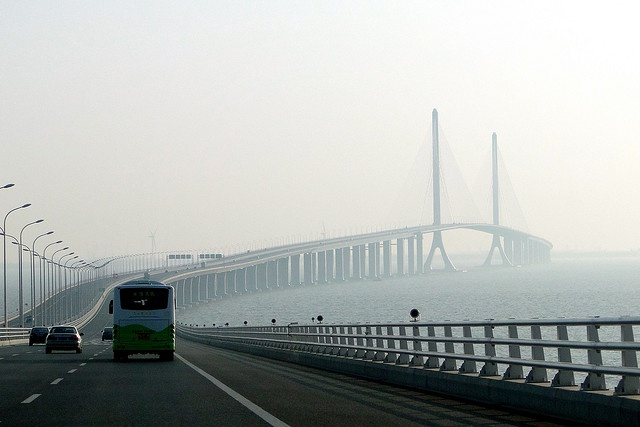Describe the objects in this image and their specific colors. I can see bus in lightgray, black, darkblue, blue, and gray tones, car in lightgray, black, gray, darkgray, and teal tones, car in lightgray, black, gray, purple, and darkblue tones, and car in lightgray, black, darkgray, purple, and gray tones in this image. 